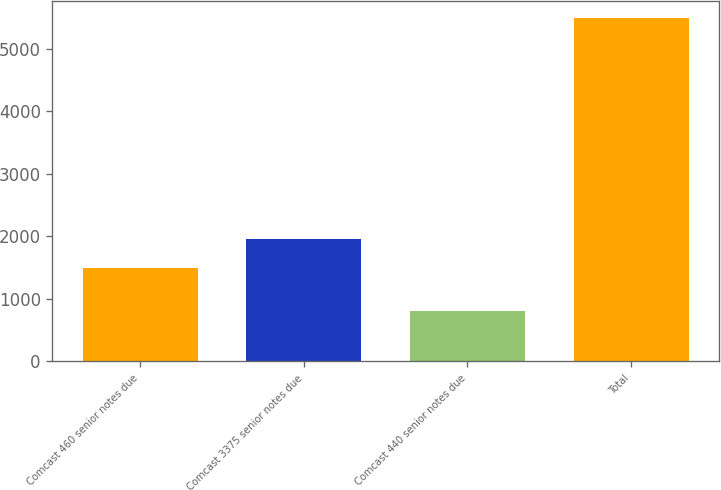Convert chart. <chart><loc_0><loc_0><loc_500><loc_500><bar_chart><fcel>Comcast 460 senior notes due<fcel>Comcast 3375 senior notes due<fcel>Comcast 440 senior notes due<fcel>Total<nl><fcel>1490<fcel>1959<fcel>800<fcel>5490<nl></chart> 